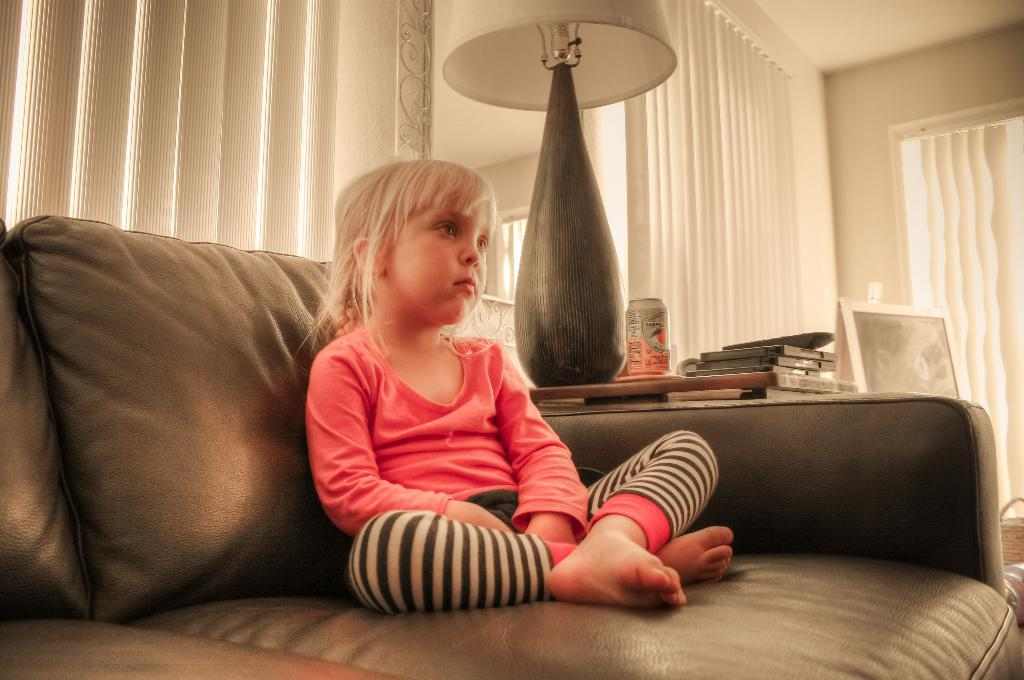Who is the main subject in the image? There is a girl in the image. What is the girl doing in the image? The girl is sitting on a sofa. What can be seen at the center of the image? There is a lamp at the center of the image. What items are on the desk in the image? There are books on a desk. What type of window treatment is present in the image? There are curtains in the area of the image. How many pies are being requested by the girl in the image? There is no mention of pies or a request in the image. What is the end result of the girl sitting on the sofa in the image? The image does not depict a specific end result or outcome of the girl sitting on the sofa. 